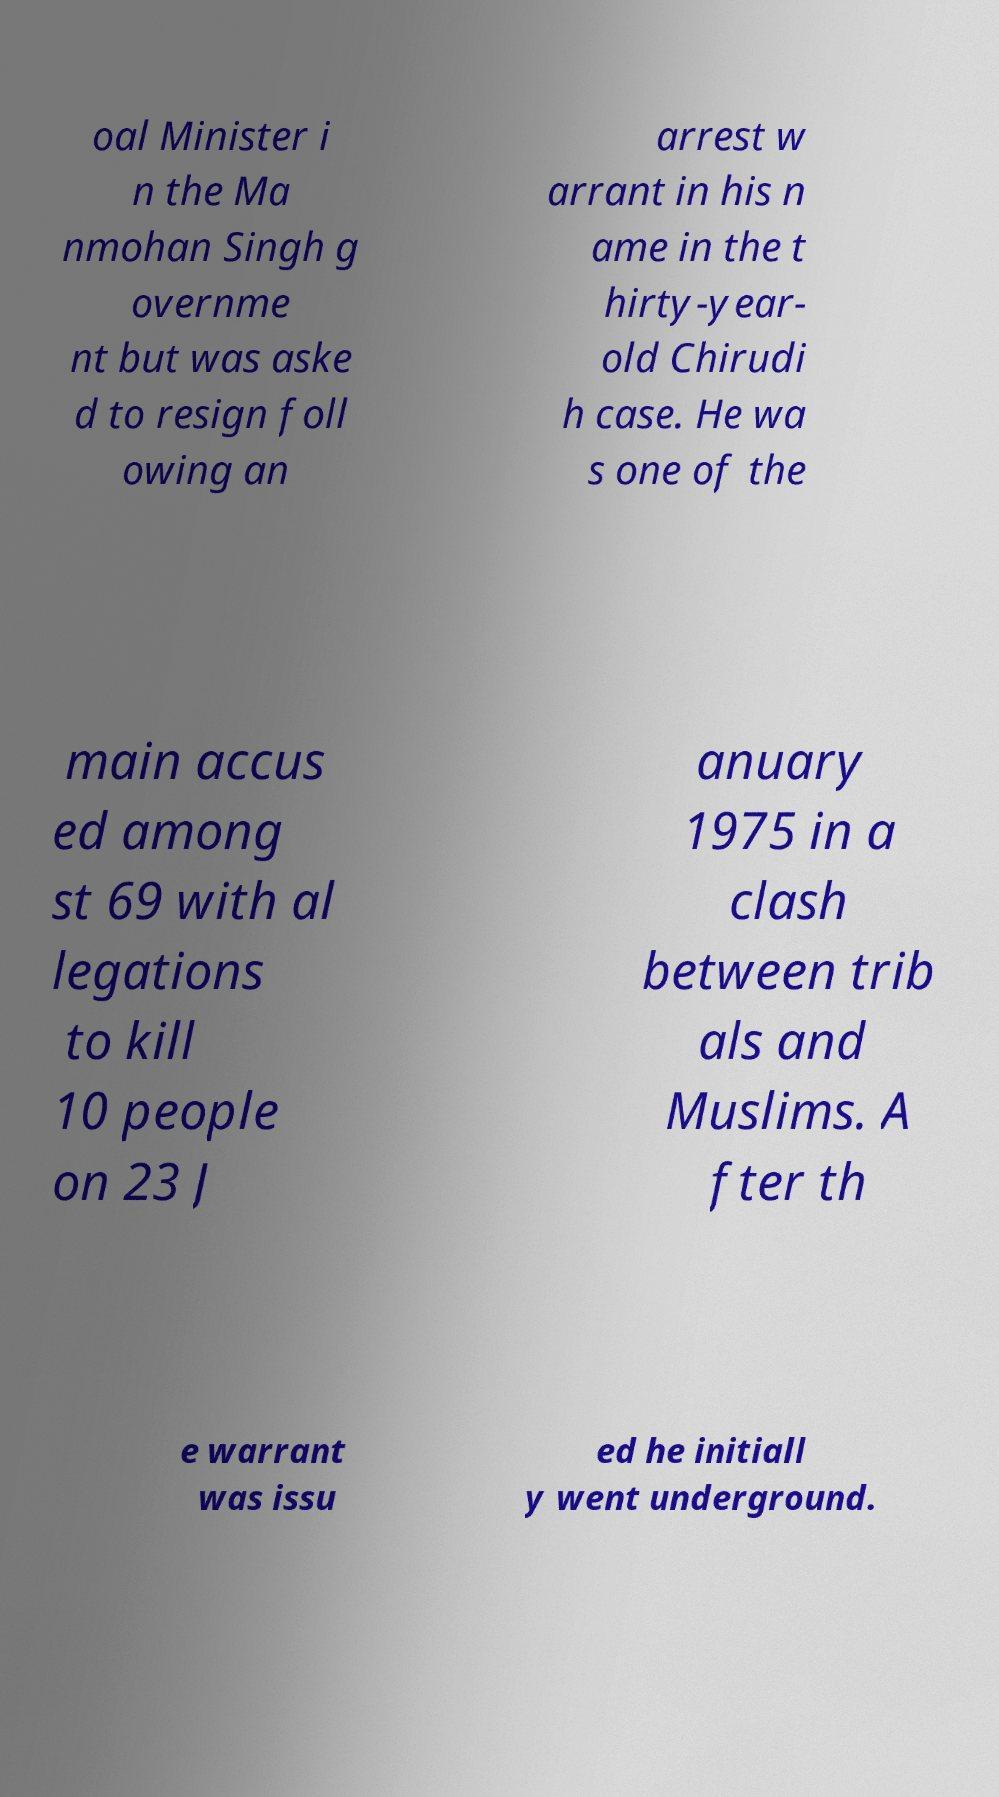Could you assist in decoding the text presented in this image and type it out clearly? oal Minister i n the Ma nmohan Singh g overnme nt but was aske d to resign foll owing an arrest w arrant in his n ame in the t hirty-year- old Chirudi h case. He wa s one of the main accus ed among st 69 with al legations to kill 10 people on 23 J anuary 1975 in a clash between trib als and Muslims. A fter th e warrant was issu ed he initiall y went underground. 